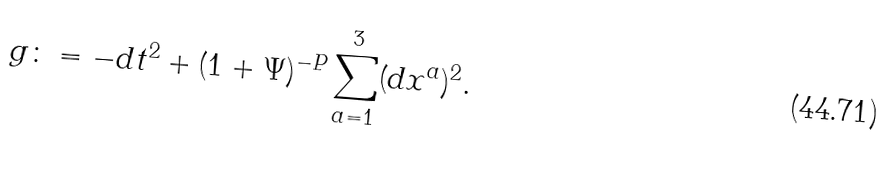<formula> <loc_0><loc_0><loc_500><loc_500>g \colon = - d t ^ { 2 } + ( 1 + \Psi ) ^ { - P } \sum _ { a = 1 } ^ { 3 } ( d x ^ { a } ) ^ { 2 } .</formula> 